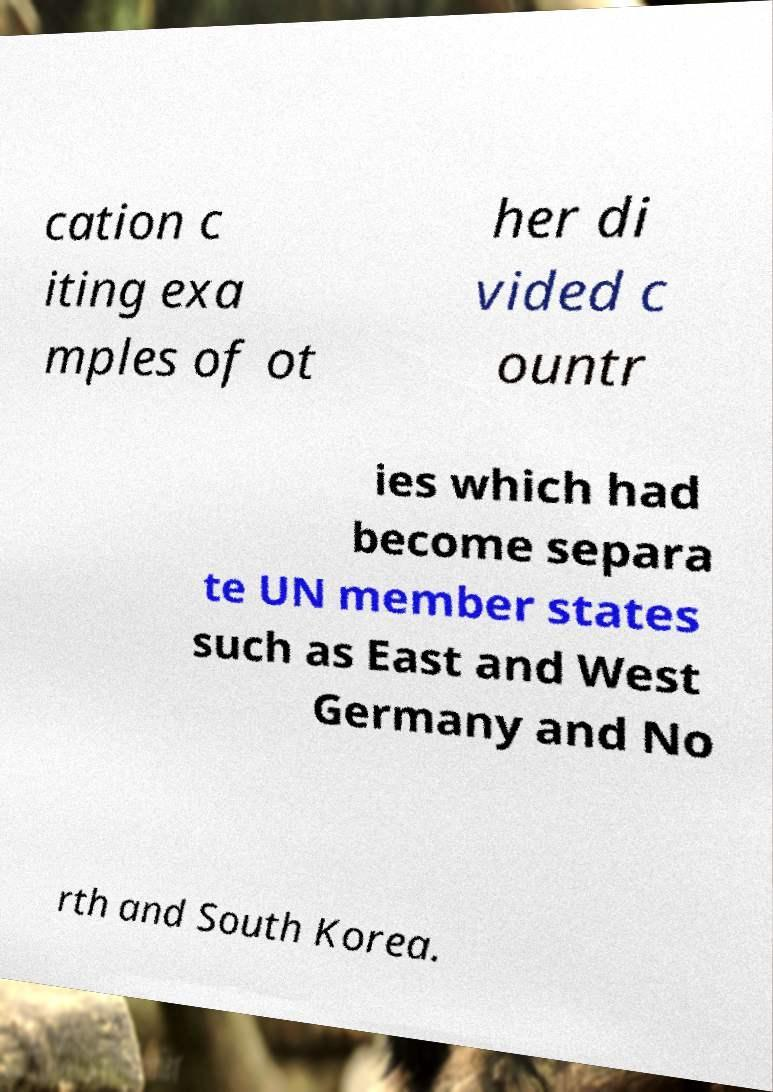Could you assist in decoding the text presented in this image and type it out clearly? cation c iting exa mples of ot her di vided c ountr ies which had become separa te UN member states such as East and West Germany and No rth and South Korea. 